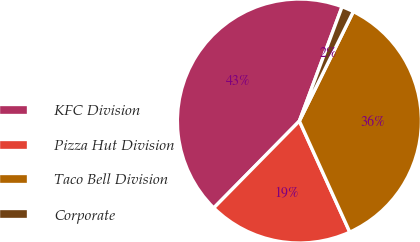Convert chart to OTSL. <chart><loc_0><loc_0><loc_500><loc_500><pie_chart><fcel>KFC Division<fcel>Pizza Hut Division<fcel>Taco Bell Division<fcel>Corporate<nl><fcel>43.31%<fcel>19.16%<fcel>35.93%<fcel>1.6%<nl></chart> 